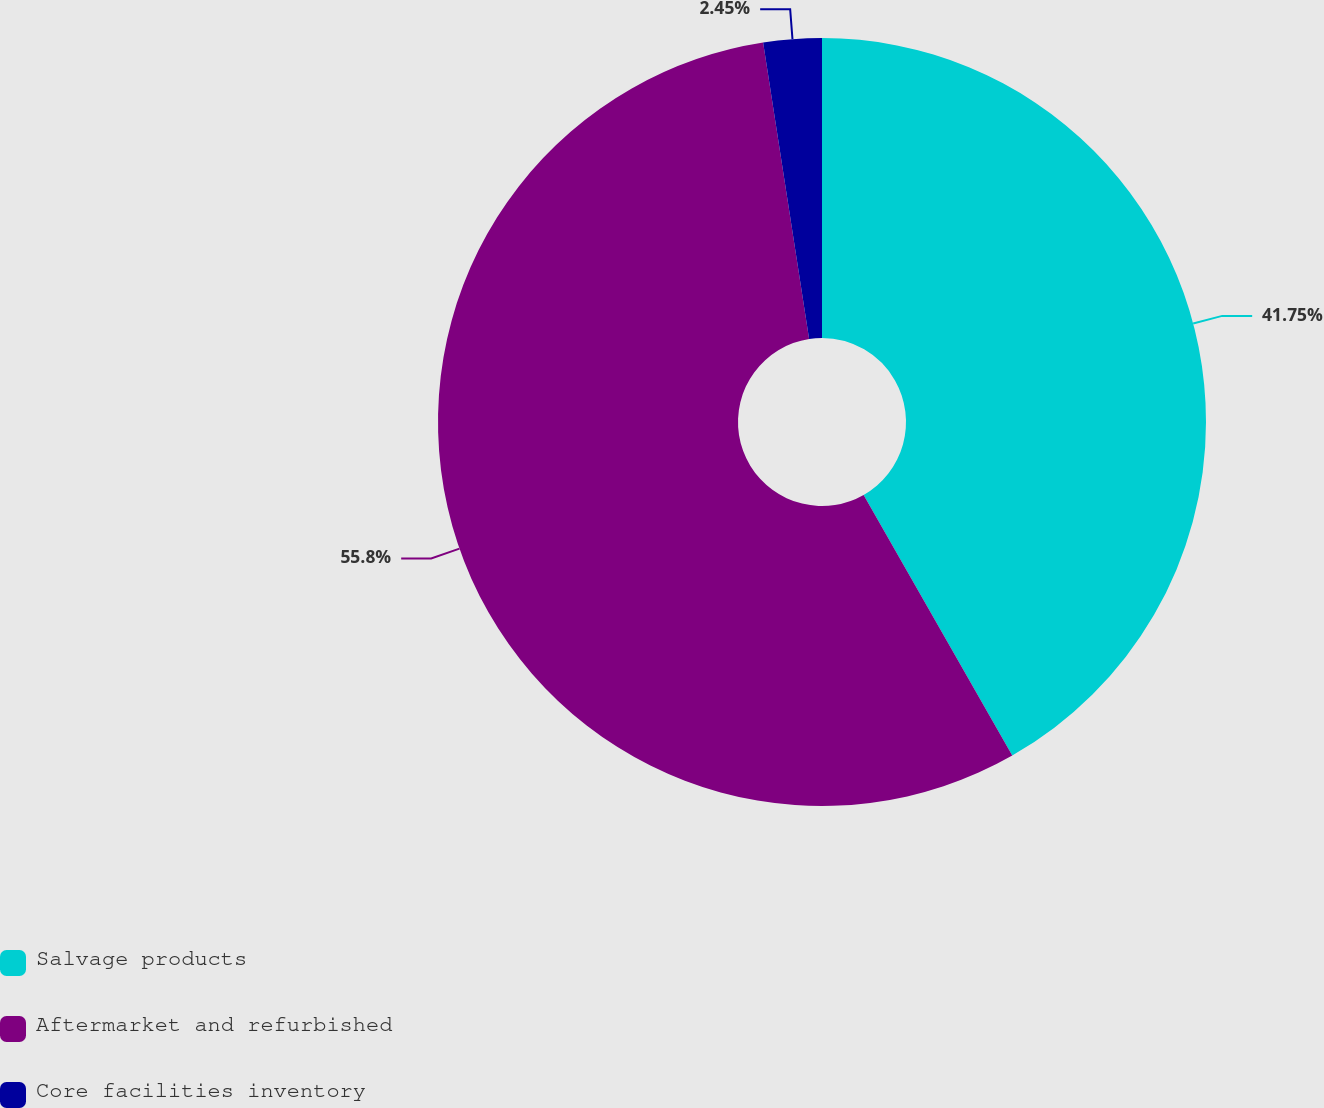<chart> <loc_0><loc_0><loc_500><loc_500><pie_chart><fcel>Salvage products<fcel>Aftermarket and refurbished<fcel>Core facilities inventory<nl><fcel>41.75%<fcel>55.8%<fcel>2.45%<nl></chart> 